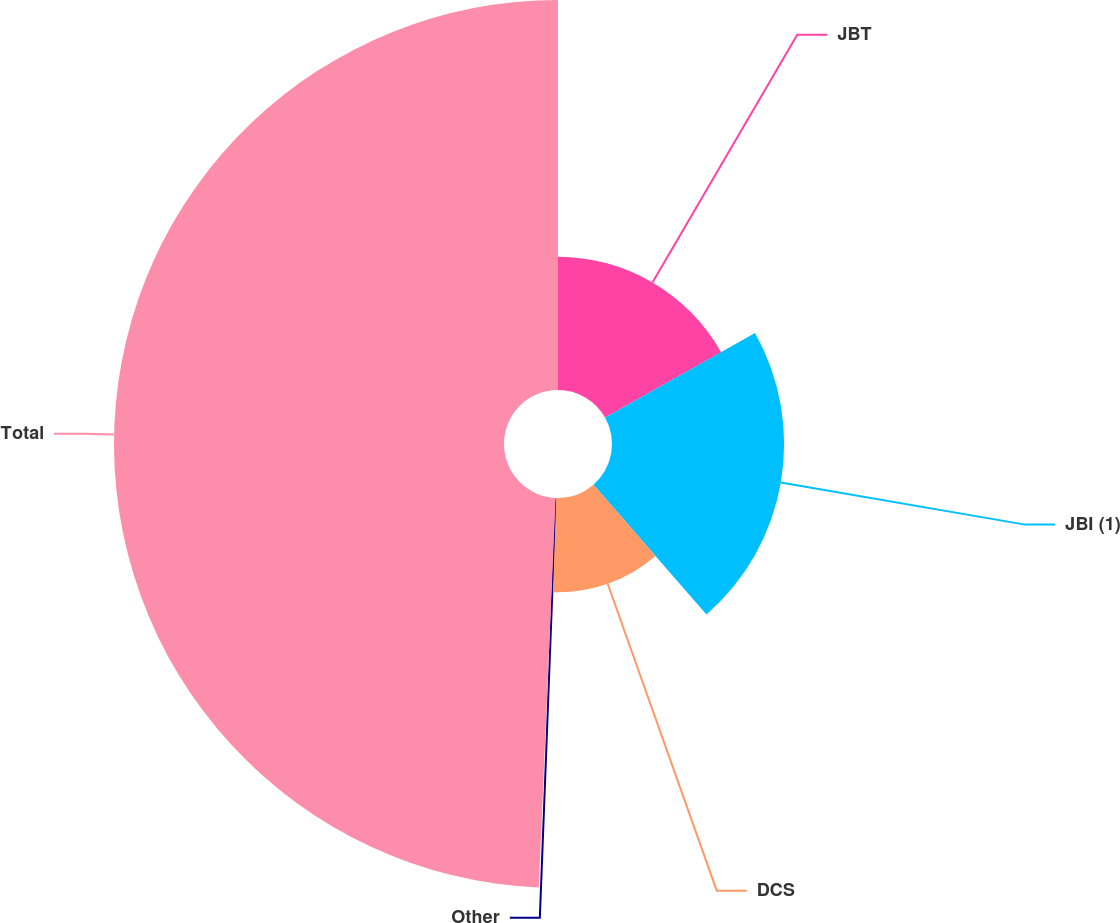Convert chart. <chart><loc_0><loc_0><loc_500><loc_500><pie_chart><fcel>JBT<fcel>JBI (1)<fcel>DCS<fcel>Other<fcel>Total<nl><fcel>16.84%<fcel>21.76%<fcel>11.93%<fcel>0.16%<fcel>49.31%<nl></chart> 